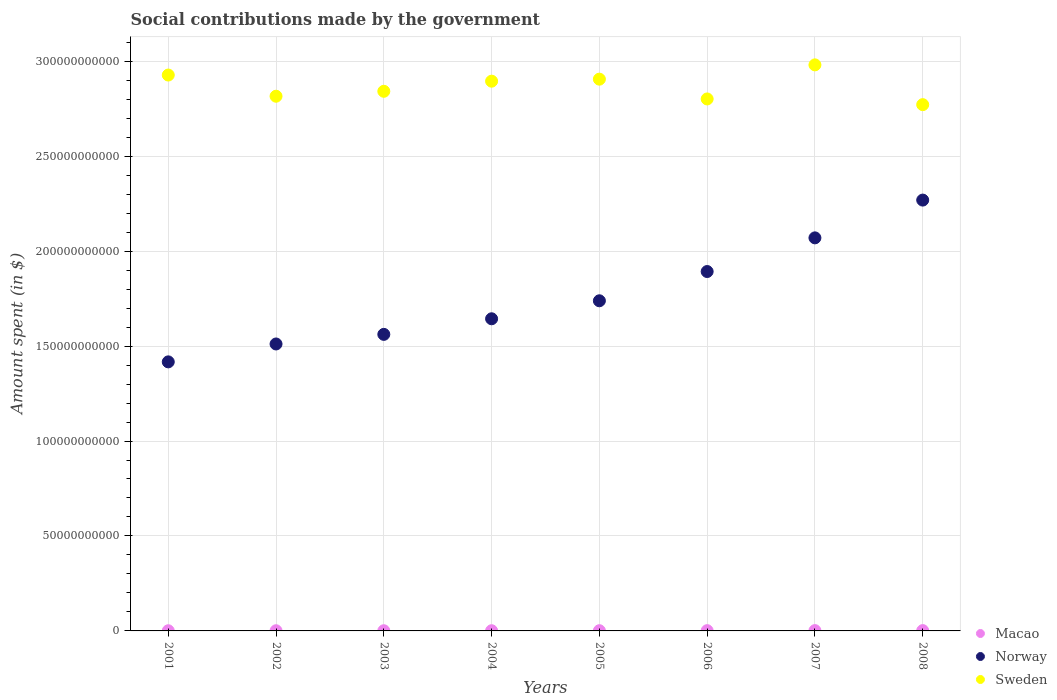Is the number of dotlines equal to the number of legend labels?
Offer a very short reply. Yes. What is the amount spent on social contributions in Macao in 2001?
Your response must be concise. 9.05e+07. Across all years, what is the maximum amount spent on social contributions in Norway?
Your answer should be very brief. 2.27e+11. Across all years, what is the minimum amount spent on social contributions in Norway?
Offer a terse response. 1.42e+11. In which year was the amount spent on social contributions in Macao minimum?
Provide a short and direct response. 2001. What is the total amount spent on social contributions in Sweden in the graph?
Provide a short and direct response. 2.29e+12. What is the difference between the amount spent on social contributions in Macao in 2001 and that in 2007?
Your answer should be compact. -7.59e+07. What is the difference between the amount spent on social contributions in Sweden in 2003 and the amount spent on social contributions in Norway in 2005?
Give a very brief answer. 1.10e+11. What is the average amount spent on social contributions in Sweden per year?
Your answer should be very brief. 2.87e+11. In the year 2005, what is the difference between the amount spent on social contributions in Macao and amount spent on social contributions in Norway?
Provide a succinct answer. -1.74e+11. What is the ratio of the amount spent on social contributions in Macao in 2003 to that in 2007?
Your answer should be very brief. 0.59. Is the amount spent on social contributions in Macao in 2004 less than that in 2006?
Make the answer very short. Yes. Is the difference between the amount spent on social contributions in Macao in 2002 and 2005 greater than the difference between the amount spent on social contributions in Norway in 2002 and 2005?
Make the answer very short. Yes. What is the difference between the highest and the second highest amount spent on social contributions in Norway?
Provide a short and direct response. 1.99e+1. What is the difference between the highest and the lowest amount spent on social contributions in Macao?
Your answer should be very brief. 7.59e+07. In how many years, is the amount spent on social contributions in Macao greater than the average amount spent on social contributions in Macao taken over all years?
Your response must be concise. 3. Is it the case that in every year, the sum of the amount spent on social contributions in Macao and amount spent on social contributions in Norway  is greater than the amount spent on social contributions in Sweden?
Make the answer very short. No. Does the amount spent on social contributions in Sweden monotonically increase over the years?
Make the answer very short. No. Is the amount spent on social contributions in Macao strictly greater than the amount spent on social contributions in Norway over the years?
Your answer should be compact. No. How many dotlines are there?
Offer a very short reply. 3. How many years are there in the graph?
Give a very brief answer. 8. What is the difference between two consecutive major ticks on the Y-axis?
Your answer should be very brief. 5.00e+1. Where does the legend appear in the graph?
Give a very brief answer. Bottom right. What is the title of the graph?
Ensure brevity in your answer.  Social contributions made by the government. What is the label or title of the X-axis?
Keep it short and to the point. Years. What is the label or title of the Y-axis?
Give a very brief answer. Amount spent (in $). What is the Amount spent (in $) in Macao in 2001?
Give a very brief answer. 9.05e+07. What is the Amount spent (in $) in Norway in 2001?
Keep it short and to the point. 1.42e+11. What is the Amount spent (in $) of Sweden in 2001?
Your response must be concise. 2.93e+11. What is the Amount spent (in $) of Macao in 2002?
Your response must be concise. 9.58e+07. What is the Amount spent (in $) of Norway in 2002?
Ensure brevity in your answer.  1.51e+11. What is the Amount spent (in $) of Sweden in 2002?
Your answer should be very brief. 2.82e+11. What is the Amount spent (in $) in Macao in 2003?
Ensure brevity in your answer.  9.80e+07. What is the Amount spent (in $) in Norway in 2003?
Offer a very short reply. 1.56e+11. What is the Amount spent (in $) of Sweden in 2003?
Your answer should be compact. 2.84e+11. What is the Amount spent (in $) of Macao in 2004?
Provide a short and direct response. 1.06e+08. What is the Amount spent (in $) in Norway in 2004?
Your response must be concise. 1.64e+11. What is the Amount spent (in $) of Sweden in 2004?
Make the answer very short. 2.89e+11. What is the Amount spent (in $) of Macao in 2005?
Make the answer very short. 1.18e+08. What is the Amount spent (in $) in Norway in 2005?
Offer a very short reply. 1.74e+11. What is the Amount spent (in $) in Sweden in 2005?
Provide a short and direct response. 2.91e+11. What is the Amount spent (in $) in Macao in 2006?
Keep it short and to the point. 1.37e+08. What is the Amount spent (in $) in Norway in 2006?
Provide a short and direct response. 1.89e+11. What is the Amount spent (in $) in Sweden in 2006?
Your answer should be very brief. 2.80e+11. What is the Amount spent (in $) in Macao in 2007?
Give a very brief answer. 1.66e+08. What is the Amount spent (in $) of Norway in 2007?
Your answer should be very brief. 2.07e+11. What is the Amount spent (in $) of Sweden in 2007?
Give a very brief answer. 2.98e+11. What is the Amount spent (in $) of Macao in 2008?
Keep it short and to the point. 1.65e+08. What is the Amount spent (in $) of Norway in 2008?
Make the answer very short. 2.27e+11. What is the Amount spent (in $) of Sweden in 2008?
Your response must be concise. 2.77e+11. Across all years, what is the maximum Amount spent (in $) of Macao?
Make the answer very short. 1.66e+08. Across all years, what is the maximum Amount spent (in $) of Norway?
Make the answer very short. 2.27e+11. Across all years, what is the maximum Amount spent (in $) in Sweden?
Your answer should be compact. 2.98e+11. Across all years, what is the minimum Amount spent (in $) in Macao?
Make the answer very short. 9.05e+07. Across all years, what is the minimum Amount spent (in $) in Norway?
Offer a very short reply. 1.42e+11. Across all years, what is the minimum Amount spent (in $) in Sweden?
Your answer should be compact. 2.77e+11. What is the total Amount spent (in $) in Macao in the graph?
Keep it short and to the point. 9.76e+08. What is the total Amount spent (in $) in Norway in the graph?
Your answer should be compact. 1.41e+12. What is the total Amount spent (in $) of Sweden in the graph?
Ensure brevity in your answer.  2.29e+12. What is the difference between the Amount spent (in $) of Macao in 2001 and that in 2002?
Your answer should be very brief. -5.26e+06. What is the difference between the Amount spent (in $) in Norway in 2001 and that in 2002?
Offer a very short reply. -9.42e+09. What is the difference between the Amount spent (in $) in Sweden in 2001 and that in 2002?
Your response must be concise. 1.12e+1. What is the difference between the Amount spent (in $) of Macao in 2001 and that in 2003?
Offer a terse response. -7.53e+06. What is the difference between the Amount spent (in $) of Norway in 2001 and that in 2003?
Your answer should be very brief. -1.45e+1. What is the difference between the Amount spent (in $) in Sweden in 2001 and that in 2003?
Provide a succinct answer. 8.56e+09. What is the difference between the Amount spent (in $) in Macao in 2001 and that in 2004?
Provide a short and direct response. -1.50e+07. What is the difference between the Amount spent (in $) of Norway in 2001 and that in 2004?
Keep it short and to the point. -2.27e+1. What is the difference between the Amount spent (in $) of Sweden in 2001 and that in 2004?
Your answer should be compact. 3.23e+09. What is the difference between the Amount spent (in $) in Macao in 2001 and that in 2005?
Offer a terse response. -2.75e+07. What is the difference between the Amount spent (in $) in Norway in 2001 and that in 2005?
Provide a succinct answer. -3.22e+1. What is the difference between the Amount spent (in $) in Sweden in 2001 and that in 2005?
Provide a succinct answer. 2.17e+09. What is the difference between the Amount spent (in $) of Macao in 2001 and that in 2006?
Provide a short and direct response. -4.65e+07. What is the difference between the Amount spent (in $) in Norway in 2001 and that in 2006?
Offer a very short reply. -4.76e+1. What is the difference between the Amount spent (in $) in Sweden in 2001 and that in 2006?
Your response must be concise. 1.26e+1. What is the difference between the Amount spent (in $) in Macao in 2001 and that in 2007?
Your response must be concise. -7.59e+07. What is the difference between the Amount spent (in $) of Norway in 2001 and that in 2007?
Offer a very short reply. -6.53e+1. What is the difference between the Amount spent (in $) of Sweden in 2001 and that in 2007?
Make the answer very short. -5.36e+09. What is the difference between the Amount spent (in $) in Macao in 2001 and that in 2008?
Your answer should be very brief. -7.40e+07. What is the difference between the Amount spent (in $) of Norway in 2001 and that in 2008?
Your answer should be compact. -8.52e+1. What is the difference between the Amount spent (in $) in Sweden in 2001 and that in 2008?
Make the answer very short. 1.56e+1. What is the difference between the Amount spent (in $) of Macao in 2002 and that in 2003?
Ensure brevity in your answer.  -2.28e+06. What is the difference between the Amount spent (in $) in Norway in 2002 and that in 2003?
Keep it short and to the point. -5.06e+09. What is the difference between the Amount spent (in $) in Sweden in 2002 and that in 2003?
Your answer should be very brief. -2.60e+09. What is the difference between the Amount spent (in $) in Macao in 2002 and that in 2004?
Your answer should be compact. -9.77e+06. What is the difference between the Amount spent (in $) in Norway in 2002 and that in 2004?
Ensure brevity in your answer.  -1.33e+1. What is the difference between the Amount spent (in $) in Sweden in 2002 and that in 2004?
Give a very brief answer. -7.92e+09. What is the difference between the Amount spent (in $) in Macao in 2002 and that in 2005?
Offer a terse response. -2.22e+07. What is the difference between the Amount spent (in $) of Norway in 2002 and that in 2005?
Provide a succinct answer. -2.27e+1. What is the difference between the Amount spent (in $) in Sweden in 2002 and that in 2005?
Offer a very short reply. -8.98e+09. What is the difference between the Amount spent (in $) of Macao in 2002 and that in 2006?
Your response must be concise. -4.12e+07. What is the difference between the Amount spent (in $) in Norway in 2002 and that in 2006?
Provide a succinct answer. -3.82e+1. What is the difference between the Amount spent (in $) in Sweden in 2002 and that in 2006?
Keep it short and to the point. 1.43e+09. What is the difference between the Amount spent (in $) of Macao in 2002 and that in 2007?
Provide a short and direct response. -7.06e+07. What is the difference between the Amount spent (in $) of Norway in 2002 and that in 2007?
Your answer should be very brief. -5.59e+1. What is the difference between the Amount spent (in $) in Sweden in 2002 and that in 2007?
Your response must be concise. -1.65e+1. What is the difference between the Amount spent (in $) in Macao in 2002 and that in 2008?
Offer a terse response. -6.88e+07. What is the difference between the Amount spent (in $) in Norway in 2002 and that in 2008?
Offer a very short reply. -7.58e+1. What is the difference between the Amount spent (in $) of Sweden in 2002 and that in 2008?
Provide a short and direct response. 4.44e+09. What is the difference between the Amount spent (in $) in Macao in 2003 and that in 2004?
Make the answer very short. -7.49e+06. What is the difference between the Amount spent (in $) of Norway in 2003 and that in 2004?
Offer a terse response. -8.21e+09. What is the difference between the Amount spent (in $) of Sweden in 2003 and that in 2004?
Offer a terse response. -5.32e+09. What is the difference between the Amount spent (in $) of Macao in 2003 and that in 2005?
Provide a succinct answer. -2.00e+07. What is the difference between the Amount spent (in $) of Norway in 2003 and that in 2005?
Your answer should be very brief. -1.77e+1. What is the difference between the Amount spent (in $) in Sweden in 2003 and that in 2005?
Give a very brief answer. -6.39e+09. What is the difference between the Amount spent (in $) of Macao in 2003 and that in 2006?
Your answer should be compact. -3.90e+07. What is the difference between the Amount spent (in $) of Norway in 2003 and that in 2006?
Ensure brevity in your answer.  -3.31e+1. What is the difference between the Amount spent (in $) of Sweden in 2003 and that in 2006?
Provide a short and direct response. 4.03e+09. What is the difference between the Amount spent (in $) in Macao in 2003 and that in 2007?
Your response must be concise. -6.83e+07. What is the difference between the Amount spent (in $) in Norway in 2003 and that in 2007?
Offer a terse response. -5.08e+1. What is the difference between the Amount spent (in $) in Sweden in 2003 and that in 2007?
Your answer should be compact. -1.39e+1. What is the difference between the Amount spent (in $) in Macao in 2003 and that in 2008?
Make the answer very short. -6.65e+07. What is the difference between the Amount spent (in $) of Norway in 2003 and that in 2008?
Offer a terse response. -7.07e+1. What is the difference between the Amount spent (in $) of Sweden in 2003 and that in 2008?
Your response must be concise. 7.04e+09. What is the difference between the Amount spent (in $) in Macao in 2004 and that in 2005?
Provide a succinct answer. -1.25e+07. What is the difference between the Amount spent (in $) in Norway in 2004 and that in 2005?
Your answer should be very brief. -9.48e+09. What is the difference between the Amount spent (in $) of Sweden in 2004 and that in 2005?
Offer a terse response. -1.06e+09. What is the difference between the Amount spent (in $) in Macao in 2004 and that in 2006?
Your answer should be very brief. -3.15e+07. What is the difference between the Amount spent (in $) of Norway in 2004 and that in 2006?
Your answer should be very brief. -2.49e+1. What is the difference between the Amount spent (in $) in Sweden in 2004 and that in 2006?
Provide a succinct answer. 9.35e+09. What is the difference between the Amount spent (in $) of Macao in 2004 and that in 2007?
Keep it short and to the point. -6.09e+07. What is the difference between the Amount spent (in $) in Norway in 2004 and that in 2007?
Offer a very short reply. -4.26e+1. What is the difference between the Amount spent (in $) of Sweden in 2004 and that in 2007?
Provide a succinct answer. -8.59e+09. What is the difference between the Amount spent (in $) in Macao in 2004 and that in 2008?
Keep it short and to the point. -5.90e+07. What is the difference between the Amount spent (in $) in Norway in 2004 and that in 2008?
Give a very brief answer. -6.25e+1. What is the difference between the Amount spent (in $) of Sweden in 2004 and that in 2008?
Your answer should be very brief. 1.24e+1. What is the difference between the Amount spent (in $) of Macao in 2005 and that in 2006?
Your answer should be compact. -1.90e+07. What is the difference between the Amount spent (in $) of Norway in 2005 and that in 2006?
Provide a short and direct response. -1.54e+1. What is the difference between the Amount spent (in $) of Sweden in 2005 and that in 2006?
Give a very brief answer. 1.04e+1. What is the difference between the Amount spent (in $) in Macao in 2005 and that in 2007?
Give a very brief answer. -4.84e+07. What is the difference between the Amount spent (in $) of Norway in 2005 and that in 2007?
Your answer should be compact. -3.31e+1. What is the difference between the Amount spent (in $) in Sweden in 2005 and that in 2007?
Make the answer very short. -7.53e+09. What is the difference between the Amount spent (in $) in Macao in 2005 and that in 2008?
Offer a very short reply. -4.65e+07. What is the difference between the Amount spent (in $) of Norway in 2005 and that in 2008?
Make the answer very short. -5.30e+1. What is the difference between the Amount spent (in $) in Sweden in 2005 and that in 2008?
Your answer should be compact. 1.34e+1. What is the difference between the Amount spent (in $) in Macao in 2006 and that in 2007?
Give a very brief answer. -2.94e+07. What is the difference between the Amount spent (in $) of Norway in 2006 and that in 2007?
Keep it short and to the point. -1.77e+1. What is the difference between the Amount spent (in $) in Sweden in 2006 and that in 2007?
Provide a short and direct response. -1.79e+1. What is the difference between the Amount spent (in $) of Macao in 2006 and that in 2008?
Your response must be concise. -2.75e+07. What is the difference between the Amount spent (in $) in Norway in 2006 and that in 2008?
Keep it short and to the point. -3.76e+1. What is the difference between the Amount spent (in $) in Sweden in 2006 and that in 2008?
Make the answer very short. 3.01e+09. What is the difference between the Amount spent (in $) in Macao in 2007 and that in 2008?
Provide a succinct answer. 1.84e+06. What is the difference between the Amount spent (in $) of Norway in 2007 and that in 2008?
Keep it short and to the point. -1.99e+1. What is the difference between the Amount spent (in $) in Sweden in 2007 and that in 2008?
Offer a terse response. 2.09e+1. What is the difference between the Amount spent (in $) of Macao in 2001 and the Amount spent (in $) of Norway in 2002?
Make the answer very short. -1.51e+11. What is the difference between the Amount spent (in $) of Macao in 2001 and the Amount spent (in $) of Sweden in 2002?
Your response must be concise. -2.81e+11. What is the difference between the Amount spent (in $) in Norway in 2001 and the Amount spent (in $) in Sweden in 2002?
Provide a short and direct response. -1.40e+11. What is the difference between the Amount spent (in $) of Macao in 2001 and the Amount spent (in $) of Norway in 2003?
Your response must be concise. -1.56e+11. What is the difference between the Amount spent (in $) in Macao in 2001 and the Amount spent (in $) in Sweden in 2003?
Offer a very short reply. -2.84e+11. What is the difference between the Amount spent (in $) in Norway in 2001 and the Amount spent (in $) in Sweden in 2003?
Your answer should be very brief. -1.42e+11. What is the difference between the Amount spent (in $) of Macao in 2001 and the Amount spent (in $) of Norway in 2004?
Give a very brief answer. -1.64e+11. What is the difference between the Amount spent (in $) in Macao in 2001 and the Amount spent (in $) in Sweden in 2004?
Offer a terse response. -2.89e+11. What is the difference between the Amount spent (in $) in Norway in 2001 and the Amount spent (in $) in Sweden in 2004?
Ensure brevity in your answer.  -1.48e+11. What is the difference between the Amount spent (in $) of Macao in 2001 and the Amount spent (in $) of Norway in 2005?
Offer a terse response. -1.74e+11. What is the difference between the Amount spent (in $) in Macao in 2001 and the Amount spent (in $) in Sweden in 2005?
Keep it short and to the point. -2.90e+11. What is the difference between the Amount spent (in $) in Norway in 2001 and the Amount spent (in $) in Sweden in 2005?
Ensure brevity in your answer.  -1.49e+11. What is the difference between the Amount spent (in $) of Macao in 2001 and the Amount spent (in $) of Norway in 2006?
Provide a short and direct response. -1.89e+11. What is the difference between the Amount spent (in $) in Macao in 2001 and the Amount spent (in $) in Sweden in 2006?
Provide a short and direct response. -2.80e+11. What is the difference between the Amount spent (in $) in Norway in 2001 and the Amount spent (in $) in Sweden in 2006?
Offer a very short reply. -1.38e+11. What is the difference between the Amount spent (in $) in Macao in 2001 and the Amount spent (in $) in Norway in 2007?
Your response must be concise. -2.07e+11. What is the difference between the Amount spent (in $) in Macao in 2001 and the Amount spent (in $) in Sweden in 2007?
Provide a succinct answer. -2.98e+11. What is the difference between the Amount spent (in $) of Norway in 2001 and the Amount spent (in $) of Sweden in 2007?
Make the answer very short. -1.56e+11. What is the difference between the Amount spent (in $) in Macao in 2001 and the Amount spent (in $) in Norway in 2008?
Give a very brief answer. -2.27e+11. What is the difference between the Amount spent (in $) in Macao in 2001 and the Amount spent (in $) in Sweden in 2008?
Give a very brief answer. -2.77e+11. What is the difference between the Amount spent (in $) of Norway in 2001 and the Amount spent (in $) of Sweden in 2008?
Provide a succinct answer. -1.35e+11. What is the difference between the Amount spent (in $) of Macao in 2002 and the Amount spent (in $) of Norway in 2003?
Your answer should be very brief. -1.56e+11. What is the difference between the Amount spent (in $) in Macao in 2002 and the Amount spent (in $) in Sweden in 2003?
Your answer should be very brief. -2.84e+11. What is the difference between the Amount spent (in $) of Norway in 2002 and the Amount spent (in $) of Sweden in 2003?
Make the answer very short. -1.33e+11. What is the difference between the Amount spent (in $) in Macao in 2002 and the Amount spent (in $) in Norway in 2004?
Give a very brief answer. -1.64e+11. What is the difference between the Amount spent (in $) of Macao in 2002 and the Amount spent (in $) of Sweden in 2004?
Ensure brevity in your answer.  -2.89e+11. What is the difference between the Amount spent (in $) in Norway in 2002 and the Amount spent (in $) in Sweden in 2004?
Offer a terse response. -1.38e+11. What is the difference between the Amount spent (in $) of Macao in 2002 and the Amount spent (in $) of Norway in 2005?
Give a very brief answer. -1.74e+11. What is the difference between the Amount spent (in $) of Macao in 2002 and the Amount spent (in $) of Sweden in 2005?
Offer a very short reply. -2.90e+11. What is the difference between the Amount spent (in $) of Norway in 2002 and the Amount spent (in $) of Sweden in 2005?
Your response must be concise. -1.39e+11. What is the difference between the Amount spent (in $) of Macao in 2002 and the Amount spent (in $) of Norway in 2006?
Your response must be concise. -1.89e+11. What is the difference between the Amount spent (in $) in Macao in 2002 and the Amount spent (in $) in Sweden in 2006?
Make the answer very short. -2.80e+11. What is the difference between the Amount spent (in $) of Norway in 2002 and the Amount spent (in $) of Sweden in 2006?
Provide a succinct answer. -1.29e+11. What is the difference between the Amount spent (in $) in Macao in 2002 and the Amount spent (in $) in Norway in 2007?
Your answer should be compact. -2.07e+11. What is the difference between the Amount spent (in $) of Macao in 2002 and the Amount spent (in $) of Sweden in 2007?
Make the answer very short. -2.98e+11. What is the difference between the Amount spent (in $) in Norway in 2002 and the Amount spent (in $) in Sweden in 2007?
Give a very brief answer. -1.47e+11. What is the difference between the Amount spent (in $) of Macao in 2002 and the Amount spent (in $) of Norway in 2008?
Make the answer very short. -2.27e+11. What is the difference between the Amount spent (in $) in Macao in 2002 and the Amount spent (in $) in Sweden in 2008?
Make the answer very short. -2.77e+11. What is the difference between the Amount spent (in $) of Norway in 2002 and the Amount spent (in $) of Sweden in 2008?
Provide a short and direct response. -1.26e+11. What is the difference between the Amount spent (in $) in Macao in 2003 and the Amount spent (in $) in Norway in 2004?
Your response must be concise. -1.64e+11. What is the difference between the Amount spent (in $) in Macao in 2003 and the Amount spent (in $) in Sweden in 2004?
Your answer should be compact. -2.89e+11. What is the difference between the Amount spent (in $) in Norway in 2003 and the Amount spent (in $) in Sweden in 2004?
Offer a very short reply. -1.33e+11. What is the difference between the Amount spent (in $) of Macao in 2003 and the Amount spent (in $) of Norway in 2005?
Offer a very short reply. -1.74e+11. What is the difference between the Amount spent (in $) in Macao in 2003 and the Amount spent (in $) in Sweden in 2005?
Offer a very short reply. -2.90e+11. What is the difference between the Amount spent (in $) of Norway in 2003 and the Amount spent (in $) of Sweden in 2005?
Ensure brevity in your answer.  -1.34e+11. What is the difference between the Amount spent (in $) in Macao in 2003 and the Amount spent (in $) in Norway in 2006?
Your answer should be very brief. -1.89e+11. What is the difference between the Amount spent (in $) of Macao in 2003 and the Amount spent (in $) of Sweden in 2006?
Offer a very short reply. -2.80e+11. What is the difference between the Amount spent (in $) in Norway in 2003 and the Amount spent (in $) in Sweden in 2006?
Your answer should be compact. -1.24e+11. What is the difference between the Amount spent (in $) of Macao in 2003 and the Amount spent (in $) of Norway in 2007?
Provide a succinct answer. -2.07e+11. What is the difference between the Amount spent (in $) in Macao in 2003 and the Amount spent (in $) in Sweden in 2007?
Make the answer very short. -2.98e+11. What is the difference between the Amount spent (in $) in Norway in 2003 and the Amount spent (in $) in Sweden in 2007?
Provide a succinct answer. -1.42e+11. What is the difference between the Amount spent (in $) of Macao in 2003 and the Amount spent (in $) of Norway in 2008?
Ensure brevity in your answer.  -2.27e+11. What is the difference between the Amount spent (in $) in Macao in 2003 and the Amount spent (in $) in Sweden in 2008?
Offer a very short reply. -2.77e+11. What is the difference between the Amount spent (in $) in Norway in 2003 and the Amount spent (in $) in Sweden in 2008?
Provide a short and direct response. -1.21e+11. What is the difference between the Amount spent (in $) of Macao in 2004 and the Amount spent (in $) of Norway in 2005?
Ensure brevity in your answer.  -1.74e+11. What is the difference between the Amount spent (in $) in Macao in 2004 and the Amount spent (in $) in Sweden in 2005?
Give a very brief answer. -2.90e+11. What is the difference between the Amount spent (in $) of Norway in 2004 and the Amount spent (in $) of Sweden in 2005?
Provide a succinct answer. -1.26e+11. What is the difference between the Amount spent (in $) in Macao in 2004 and the Amount spent (in $) in Norway in 2006?
Your response must be concise. -1.89e+11. What is the difference between the Amount spent (in $) of Macao in 2004 and the Amount spent (in $) of Sweden in 2006?
Your answer should be very brief. -2.80e+11. What is the difference between the Amount spent (in $) of Norway in 2004 and the Amount spent (in $) of Sweden in 2006?
Provide a succinct answer. -1.16e+11. What is the difference between the Amount spent (in $) of Macao in 2004 and the Amount spent (in $) of Norway in 2007?
Give a very brief answer. -2.07e+11. What is the difference between the Amount spent (in $) in Macao in 2004 and the Amount spent (in $) in Sweden in 2007?
Offer a very short reply. -2.98e+11. What is the difference between the Amount spent (in $) of Norway in 2004 and the Amount spent (in $) of Sweden in 2007?
Make the answer very short. -1.34e+11. What is the difference between the Amount spent (in $) in Macao in 2004 and the Amount spent (in $) in Norway in 2008?
Offer a terse response. -2.27e+11. What is the difference between the Amount spent (in $) of Macao in 2004 and the Amount spent (in $) of Sweden in 2008?
Provide a short and direct response. -2.77e+11. What is the difference between the Amount spent (in $) of Norway in 2004 and the Amount spent (in $) of Sweden in 2008?
Provide a succinct answer. -1.13e+11. What is the difference between the Amount spent (in $) of Macao in 2005 and the Amount spent (in $) of Norway in 2006?
Your response must be concise. -1.89e+11. What is the difference between the Amount spent (in $) in Macao in 2005 and the Amount spent (in $) in Sweden in 2006?
Offer a very short reply. -2.80e+11. What is the difference between the Amount spent (in $) of Norway in 2005 and the Amount spent (in $) of Sweden in 2006?
Offer a very short reply. -1.06e+11. What is the difference between the Amount spent (in $) in Macao in 2005 and the Amount spent (in $) in Norway in 2007?
Keep it short and to the point. -2.07e+11. What is the difference between the Amount spent (in $) in Macao in 2005 and the Amount spent (in $) in Sweden in 2007?
Offer a terse response. -2.98e+11. What is the difference between the Amount spent (in $) of Norway in 2005 and the Amount spent (in $) of Sweden in 2007?
Your answer should be very brief. -1.24e+11. What is the difference between the Amount spent (in $) of Macao in 2005 and the Amount spent (in $) of Norway in 2008?
Your response must be concise. -2.27e+11. What is the difference between the Amount spent (in $) of Macao in 2005 and the Amount spent (in $) of Sweden in 2008?
Your answer should be very brief. -2.77e+11. What is the difference between the Amount spent (in $) in Norway in 2005 and the Amount spent (in $) in Sweden in 2008?
Offer a terse response. -1.03e+11. What is the difference between the Amount spent (in $) in Macao in 2006 and the Amount spent (in $) in Norway in 2007?
Offer a terse response. -2.07e+11. What is the difference between the Amount spent (in $) in Macao in 2006 and the Amount spent (in $) in Sweden in 2007?
Provide a short and direct response. -2.98e+11. What is the difference between the Amount spent (in $) in Norway in 2006 and the Amount spent (in $) in Sweden in 2007?
Your answer should be compact. -1.09e+11. What is the difference between the Amount spent (in $) of Macao in 2006 and the Amount spent (in $) of Norway in 2008?
Your response must be concise. -2.27e+11. What is the difference between the Amount spent (in $) in Macao in 2006 and the Amount spent (in $) in Sweden in 2008?
Give a very brief answer. -2.77e+11. What is the difference between the Amount spent (in $) in Norway in 2006 and the Amount spent (in $) in Sweden in 2008?
Your response must be concise. -8.79e+1. What is the difference between the Amount spent (in $) in Macao in 2007 and the Amount spent (in $) in Norway in 2008?
Your answer should be very brief. -2.27e+11. What is the difference between the Amount spent (in $) in Macao in 2007 and the Amount spent (in $) in Sweden in 2008?
Offer a terse response. -2.77e+11. What is the difference between the Amount spent (in $) of Norway in 2007 and the Amount spent (in $) of Sweden in 2008?
Keep it short and to the point. -7.01e+1. What is the average Amount spent (in $) of Macao per year?
Provide a succinct answer. 1.22e+08. What is the average Amount spent (in $) of Norway per year?
Give a very brief answer. 1.76e+11. What is the average Amount spent (in $) of Sweden per year?
Give a very brief answer. 2.87e+11. In the year 2001, what is the difference between the Amount spent (in $) in Macao and Amount spent (in $) in Norway?
Your answer should be compact. -1.42e+11. In the year 2001, what is the difference between the Amount spent (in $) in Macao and Amount spent (in $) in Sweden?
Offer a terse response. -2.93e+11. In the year 2001, what is the difference between the Amount spent (in $) of Norway and Amount spent (in $) of Sweden?
Offer a terse response. -1.51e+11. In the year 2002, what is the difference between the Amount spent (in $) in Macao and Amount spent (in $) in Norway?
Provide a short and direct response. -1.51e+11. In the year 2002, what is the difference between the Amount spent (in $) of Macao and Amount spent (in $) of Sweden?
Provide a succinct answer. -2.81e+11. In the year 2002, what is the difference between the Amount spent (in $) in Norway and Amount spent (in $) in Sweden?
Your answer should be very brief. -1.30e+11. In the year 2003, what is the difference between the Amount spent (in $) of Macao and Amount spent (in $) of Norway?
Make the answer very short. -1.56e+11. In the year 2003, what is the difference between the Amount spent (in $) in Macao and Amount spent (in $) in Sweden?
Offer a very short reply. -2.84e+11. In the year 2003, what is the difference between the Amount spent (in $) in Norway and Amount spent (in $) in Sweden?
Give a very brief answer. -1.28e+11. In the year 2004, what is the difference between the Amount spent (in $) of Macao and Amount spent (in $) of Norway?
Your answer should be very brief. -1.64e+11. In the year 2004, what is the difference between the Amount spent (in $) in Macao and Amount spent (in $) in Sweden?
Offer a very short reply. -2.89e+11. In the year 2004, what is the difference between the Amount spent (in $) in Norway and Amount spent (in $) in Sweden?
Your answer should be compact. -1.25e+11. In the year 2005, what is the difference between the Amount spent (in $) of Macao and Amount spent (in $) of Norway?
Offer a terse response. -1.74e+11. In the year 2005, what is the difference between the Amount spent (in $) in Macao and Amount spent (in $) in Sweden?
Give a very brief answer. -2.90e+11. In the year 2005, what is the difference between the Amount spent (in $) in Norway and Amount spent (in $) in Sweden?
Make the answer very short. -1.17e+11. In the year 2006, what is the difference between the Amount spent (in $) in Macao and Amount spent (in $) in Norway?
Provide a succinct answer. -1.89e+11. In the year 2006, what is the difference between the Amount spent (in $) of Macao and Amount spent (in $) of Sweden?
Offer a very short reply. -2.80e+11. In the year 2006, what is the difference between the Amount spent (in $) of Norway and Amount spent (in $) of Sweden?
Provide a short and direct response. -9.09e+1. In the year 2007, what is the difference between the Amount spent (in $) of Macao and Amount spent (in $) of Norway?
Your response must be concise. -2.07e+11. In the year 2007, what is the difference between the Amount spent (in $) in Macao and Amount spent (in $) in Sweden?
Make the answer very short. -2.98e+11. In the year 2007, what is the difference between the Amount spent (in $) in Norway and Amount spent (in $) in Sweden?
Provide a short and direct response. -9.11e+1. In the year 2008, what is the difference between the Amount spent (in $) in Macao and Amount spent (in $) in Norway?
Ensure brevity in your answer.  -2.27e+11. In the year 2008, what is the difference between the Amount spent (in $) of Macao and Amount spent (in $) of Sweden?
Keep it short and to the point. -2.77e+11. In the year 2008, what is the difference between the Amount spent (in $) of Norway and Amount spent (in $) of Sweden?
Ensure brevity in your answer.  -5.03e+1. What is the ratio of the Amount spent (in $) in Macao in 2001 to that in 2002?
Provide a short and direct response. 0.95. What is the ratio of the Amount spent (in $) in Norway in 2001 to that in 2002?
Provide a succinct answer. 0.94. What is the ratio of the Amount spent (in $) of Sweden in 2001 to that in 2002?
Make the answer very short. 1.04. What is the ratio of the Amount spent (in $) of Macao in 2001 to that in 2003?
Provide a succinct answer. 0.92. What is the ratio of the Amount spent (in $) in Norway in 2001 to that in 2003?
Provide a short and direct response. 0.91. What is the ratio of the Amount spent (in $) of Sweden in 2001 to that in 2003?
Give a very brief answer. 1.03. What is the ratio of the Amount spent (in $) of Macao in 2001 to that in 2004?
Ensure brevity in your answer.  0.86. What is the ratio of the Amount spent (in $) in Norway in 2001 to that in 2004?
Offer a terse response. 0.86. What is the ratio of the Amount spent (in $) in Sweden in 2001 to that in 2004?
Offer a terse response. 1.01. What is the ratio of the Amount spent (in $) in Macao in 2001 to that in 2005?
Keep it short and to the point. 0.77. What is the ratio of the Amount spent (in $) of Norway in 2001 to that in 2005?
Make the answer very short. 0.81. What is the ratio of the Amount spent (in $) of Sweden in 2001 to that in 2005?
Offer a very short reply. 1.01. What is the ratio of the Amount spent (in $) in Macao in 2001 to that in 2006?
Your response must be concise. 0.66. What is the ratio of the Amount spent (in $) of Norway in 2001 to that in 2006?
Keep it short and to the point. 0.75. What is the ratio of the Amount spent (in $) of Sweden in 2001 to that in 2006?
Make the answer very short. 1.04. What is the ratio of the Amount spent (in $) in Macao in 2001 to that in 2007?
Your answer should be very brief. 0.54. What is the ratio of the Amount spent (in $) in Norway in 2001 to that in 2007?
Give a very brief answer. 0.68. What is the ratio of the Amount spent (in $) of Sweden in 2001 to that in 2007?
Your answer should be compact. 0.98. What is the ratio of the Amount spent (in $) of Macao in 2001 to that in 2008?
Make the answer very short. 0.55. What is the ratio of the Amount spent (in $) of Norway in 2001 to that in 2008?
Provide a succinct answer. 0.62. What is the ratio of the Amount spent (in $) in Sweden in 2001 to that in 2008?
Keep it short and to the point. 1.06. What is the ratio of the Amount spent (in $) in Macao in 2002 to that in 2003?
Your answer should be very brief. 0.98. What is the ratio of the Amount spent (in $) in Norway in 2002 to that in 2003?
Your answer should be compact. 0.97. What is the ratio of the Amount spent (in $) of Sweden in 2002 to that in 2003?
Provide a succinct answer. 0.99. What is the ratio of the Amount spent (in $) of Macao in 2002 to that in 2004?
Ensure brevity in your answer.  0.91. What is the ratio of the Amount spent (in $) of Norway in 2002 to that in 2004?
Ensure brevity in your answer.  0.92. What is the ratio of the Amount spent (in $) in Sweden in 2002 to that in 2004?
Keep it short and to the point. 0.97. What is the ratio of the Amount spent (in $) in Macao in 2002 to that in 2005?
Offer a terse response. 0.81. What is the ratio of the Amount spent (in $) of Norway in 2002 to that in 2005?
Offer a very short reply. 0.87. What is the ratio of the Amount spent (in $) of Sweden in 2002 to that in 2005?
Ensure brevity in your answer.  0.97. What is the ratio of the Amount spent (in $) of Macao in 2002 to that in 2006?
Offer a terse response. 0.7. What is the ratio of the Amount spent (in $) of Norway in 2002 to that in 2006?
Provide a succinct answer. 0.8. What is the ratio of the Amount spent (in $) of Sweden in 2002 to that in 2006?
Your answer should be compact. 1.01. What is the ratio of the Amount spent (in $) in Macao in 2002 to that in 2007?
Make the answer very short. 0.58. What is the ratio of the Amount spent (in $) of Norway in 2002 to that in 2007?
Your answer should be very brief. 0.73. What is the ratio of the Amount spent (in $) of Sweden in 2002 to that in 2007?
Your answer should be compact. 0.94. What is the ratio of the Amount spent (in $) of Macao in 2002 to that in 2008?
Provide a short and direct response. 0.58. What is the ratio of the Amount spent (in $) in Norway in 2002 to that in 2008?
Your response must be concise. 0.67. What is the ratio of the Amount spent (in $) of Sweden in 2002 to that in 2008?
Your answer should be very brief. 1.02. What is the ratio of the Amount spent (in $) in Macao in 2003 to that in 2004?
Your answer should be very brief. 0.93. What is the ratio of the Amount spent (in $) in Sweden in 2003 to that in 2004?
Your answer should be compact. 0.98. What is the ratio of the Amount spent (in $) of Macao in 2003 to that in 2005?
Provide a succinct answer. 0.83. What is the ratio of the Amount spent (in $) of Norway in 2003 to that in 2005?
Keep it short and to the point. 0.9. What is the ratio of the Amount spent (in $) in Macao in 2003 to that in 2006?
Provide a succinct answer. 0.72. What is the ratio of the Amount spent (in $) in Norway in 2003 to that in 2006?
Ensure brevity in your answer.  0.83. What is the ratio of the Amount spent (in $) of Sweden in 2003 to that in 2006?
Offer a terse response. 1.01. What is the ratio of the Amount spent (in $) in Macao in 2003 to that in 2007?
Give a very brief answer. 0.59. What is the ratio of the Amount spent (in $) of Norway in 2003 to that in 2007?
Your response must be concise. 0.75. What is the ratio of the Amount spent (in $) of Sweden in 2003 to that in 2007?
Your response must be concise. 0.95. What is the ratio of the Amount spent (in $) in Macao in 2003 to that in 2008?
Provide a succinct answer. 0.6. What is the ratio of the Amount spent (in $) in Norway in 2003 to that in 2008?
Your answer should be compact. 0.69. What is the ratio of the Amount spent (in $) in Sweden in 2003 to that in 2008?
Offer a terse response. 1.03. What is the ratio of the Amount spent (in $) in Macao in 2004 to that in 2005?
Your answer should be compact. 0.89. What is the ratio of the Amount spent (in $) of Norway in 2004 to that in 2005?
Your answer should be very brief. 0.95. What is the ratio of the Amount spent (in $) of Macao in 2004 to that in 2006?
Offer a very short reply. 0.77. What is the ratio of the Amount spent (in $) in Norway in 2004 to that in 2006?
Your answer should be very brief. 0.87. What is the ratio of the Amount spent (in $) of Sweden in 2004 to that in 2006?
Keep it short and to the point. 1.03. What is the ratio of the Amount spent (in $) of Macao in 2004 to that in 2007?
Offer a terse response. 0.63. What is the ratio of the Amount spent (in $) in Norway in 2004 to that in 2007?
Your answer should be very brief. 0.79. What is the ratio of the Amount spent (in $) in Sweden in 2004 to that in 2007?
Offer a terse response. 0.97. What is the ratio of the Amount spent (in $) in Macao in 2004 to that in 2008?
Your response must be concise. 0.64. What is the ratio of the Amount spent (in $) of Norway in 2004 to that in 2008?
Ensure brevity in your answer.  0.72. What is the ratio of the Amount spent (in $) in Sweden in 2004 to that in 2008?
Your response must be concise. 1.04. What is the ratio of the Amount spent (in $) of Macao in 2005 to that in 2006?
Provide a succinct answer. 0.86. What is the ratio of the Amount spent (in $) in Norway in 2005 to that in 2006?
Provide a short and direct response. 0.92. What is the ratio of the Amount spent (in $) of Sweden in 2005 to that in 2006?
Give a very brief answer. 1.04. What is the ratio of the Amount spent (in $) of Macao in 2005 to that in 2007?
Offer a terse response. 0.71. What is the ratio of the Amount spent (in $) of Norway in 2005 to that in 2007?
Provide a succinct answer. 0.84. What is the ratio of the Amount spent (in $) of Sweden in 2005 to that in 2007?
Provide a short and direct response. 0.97. What is the ratio of the Amount spent (in $) in Macao in 2005 to that in 2008?
Give a very brief answer. 0.72. What is the ratio of the Amount spent (in $) in Norway in 2005 to that in 2008?
Offer a terse response. 0.77. What is the ratio of the Amount spent (in $) in Sweden in 2005 to that in 2008?
Your answer should be compact. 1.05. What is the ratio of the Amount spent (in $) of Macao in 2006 to that in 2007?
Your response must be concise. 0.82. What is the ratio of the Amount spent (in $) in Norway in 2006 to that in 2007?
Offer a terse response. 0.91. What is the ratio of the Amount spent (in $) of Sweden in 2006 to that in 2007?
Keep it short and to the point. 0.94. What is the ratio of the Amount spent (in $) of Macao in 2006 to that in 2008?
Keep it short and to the point. 0.83. What is the ratio of the Amount spent (in $) in Norway in 2006 to that in 2008?
Offer a very short reply. 0.83. What is the ratio of the Amount spent (in $) in Sweden in 2006 to that in 2008?
Your response must be concise. 1.01. What is the ratio of the Amount spent (in $) in Macao in 2007 to that in 2008?
Make the answer very short. 1.01. What is the ratio of the Amount spent (in $) in Norway in 2007 to that in 2008?
Your response must be concise. 0.91. What is the ratio of the Amount spent (in $) of Sweden in 2007 to that in 2008?
Keep it short and to the point. 1.08. What is the difference between the highest and the second highest Amount spent (in $) of Macao?
Offer a very short reply. 1.84e+06. What is the difference between the highest and the second highest Amount spent (in $) of Norway?
Provide a short and direct response. 1.99e+1. What is the difference between the highest and the second highest Amount spent (in $) in Sweden?
Offer a very short reply. 5.36e+09. What is the difference between the highest and the lowest Amount spent (in $) of Macao?
Your answer should be compact. 7.59e+07. What is the difference between the highest and the lowest Amount spent (in $) in Norway?
Your answer should be very brief. 8.52e+1. What is the difference between the highest and the lowest Amount spent (in $) in Sweden?
Offer a very short reply. 2.09e+1. 